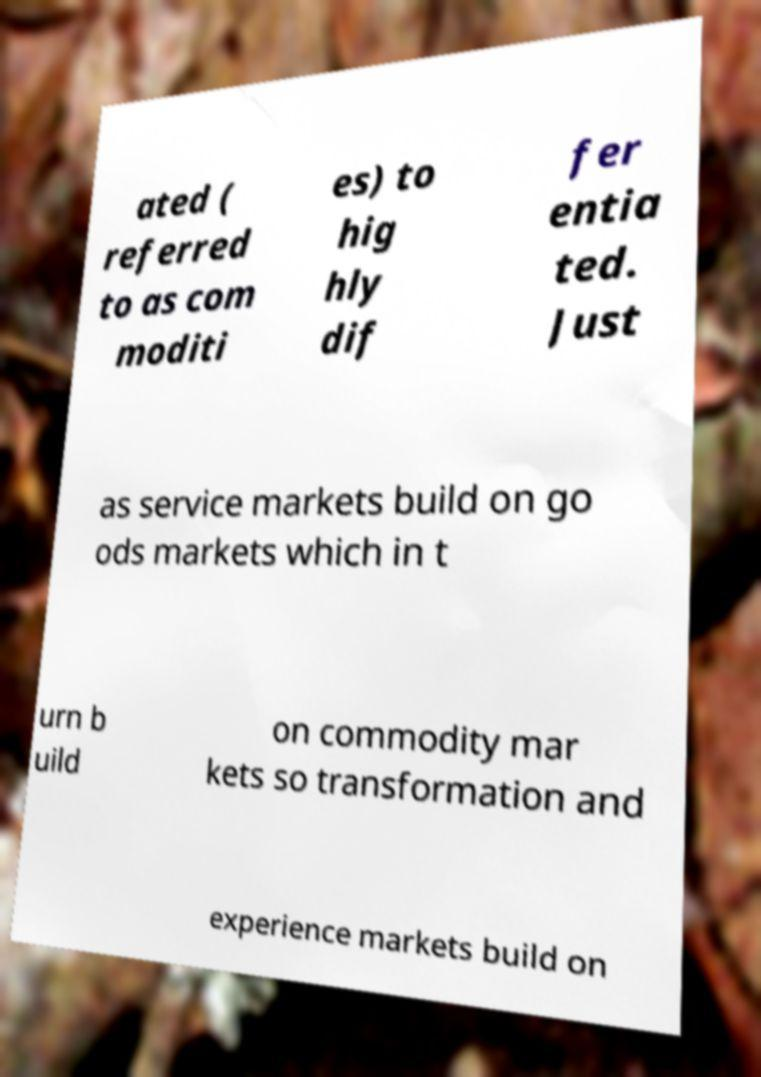Could you assist in decoding the text presented in this image and type it out clearly? ated ( referred to as com moditi es) to hig hly dif fer entia ted. Just as service markets build on go ods markets which in t urn b uild on commodity mar kets so transformation and experience markets build on 